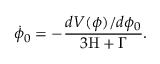<formula> <loc_0><loc_0><loc_500><loc_500>{ \dot { \phi } } _ { 0 } = - \frac { d V ( \phi ) / d \phi _ { 0 } } { 3 H + \Gamma } .</formula> 